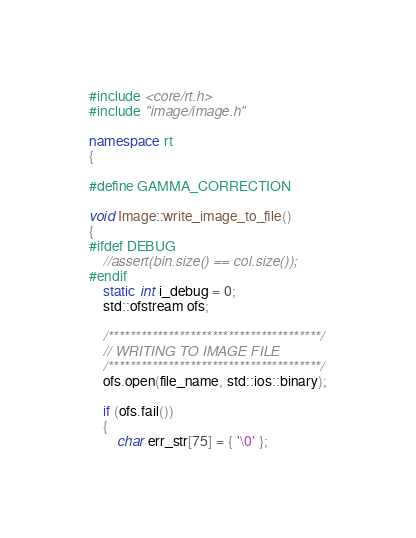<code> <loc_0><loc_0><loc_500><loc_500><_C++_>#include <core/rt.h>
#include "image/image.h"

namespace rt
{

#define GAMMA_CORRECTION

void Image::write_image_to_file()
{
#ifdef DEBUG
	//assert(bin.size() == col.size());
#endif
	static int i_debug = 0;
	std::ofstream ofs;

	/***************************************/
	// WRITING TO IMAGE FILE
	/***************************************/
	ofs.open(file_name, std::ios::binary);

	if (ofs.fail())
	{
		char err_str[75] = { '\0' };</code> 